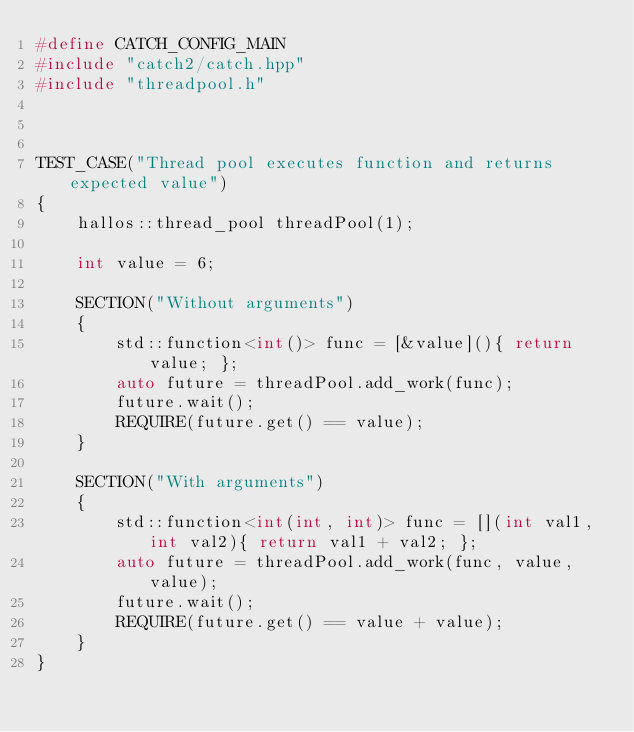<code> <loc_0><loc_0><loc_500><loc_500><_C++_>#define CATCH_CONFIG_MAIN
#include "catch2/catch.hpp"
#include "threadpool.h"



TEST_CASE("Thread pool executes function and returns expected value")
{
    hallos::thread_pool threadPool(1);

    int value = 6;

    SECTION("Without arguments")
    {
        std::function<int()> func = [&value](){ return value; };
        auto future = threadPool.add_work(func);
        future.wait();
        REQUIRE(future.get() == value);
    }

    SECTION("With arguments")
    {
        std::function<int(int, int)> func = [](int val1, int val2){ return val1 + val2; };
        auto future = threadPool.add_work(func, value, value);
        future.wait();
        REQUIRE(future.get() == value + value);
    }
}</code> 